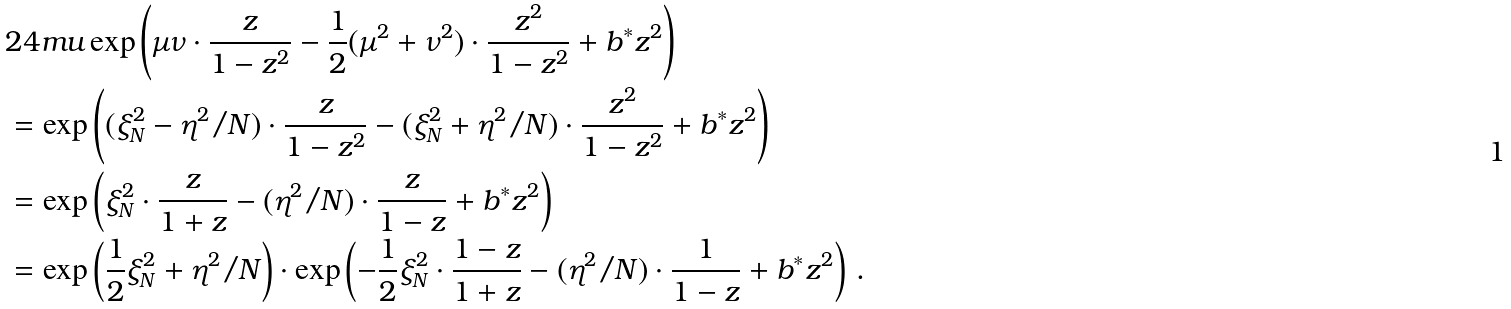Convert formula to latex. <formula><loc_0><loc_0><loc_500><loc_500>& 2 4 m u \exp \left ( \mu \nu \cdot \frac { z } { 1 - z ^ { 2 } } - \frac { 1 } { 2 } ( \mu ^ { 2 } + \nu ^ { 2 } ) \cdot \frac { z ^ { 2 } } { 1 - z ^ { 2 } } + b ^ { * } z ^ { 2 } \right ) \\ & = \exp \left ( ( \xi _ { N } ^ { 2 } - \eta ^ { 2 } / N ) \cdot \frac { z } { 1 - z ^ { 2 } } - ( \xi _ { N } ^ { 2 } + \eta ^ { 2 } / N ) \cdot \frac { z ^ { 2 } } { 1 - z ^ { 2 } } + b ^ { * } z ^ { 2 } \right ) \\ & = \exp \left ( \xi _ { N } ^ { 2 } \cdot \frac { z } { 1 + z } - ( \eta ^ { 2 } / N ) \cdot \frac { z } { 1 - z } + b ^ { * } z ^ { 2 } \right ) \\ & = \exp \left ( \frac { 1 } { 2 } \xi _ { N } ^ { 2 } + \eta ^ { 2 } / N \right ) \cdot \exp \left ( - \frac { 1 } { 2 } \xi _ { N } ^ { 2 } \cdot \frac { 1 - z } { 1 + z } - ( \eta ^ { 2 } / N ) \cdot \frac { 1 } { 1 - z } + b ^ { * } z ^ { 2 } \right ) \, .</formula> 